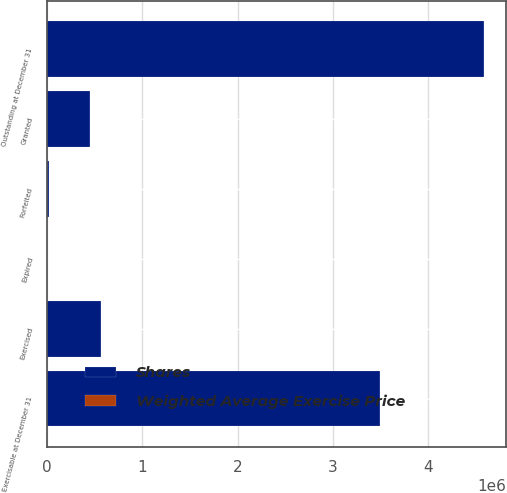Convert chart. <chart><loc_0><loc_0><loc_500><loc_500><stacked_bar_chart><ecel><fcel>Outstanding at December 31<fcel>Granted<fcel>Exercised<fcel>Forfeited<fcel>Expired<fcel>Exercisable at December 31<nl><fcel>Shares<fcel>4.58424e+06<fcel>447986<fcel>565806<fcel>23197<fcel>4141<fcel>3.49649e+06<nl><fcel>Weighted Average Exercise Price<fcel>72.03<fcel>104.42<fcel>57.91<fcel>91.73<fcel>83.7<fcel>65.96<nl></chart> 